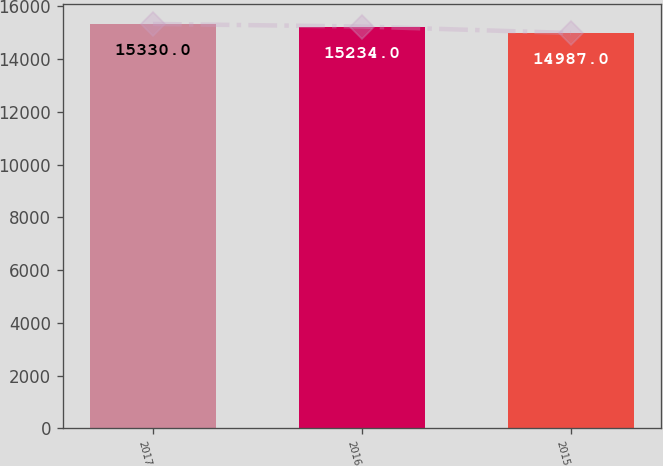<chart> <loc_0><loc_0><loc_500><loc_500><bar_chart><fcel>2017<fcel>2016<fcel>2015<nl><fcel>15330<fcel>15234<fcel>14987<nl></chart> 